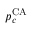Convert formula to latex. <formula><loc_0><loc_0><loc_500><loc_500>p _ { c } ^ { C A }</formula> 